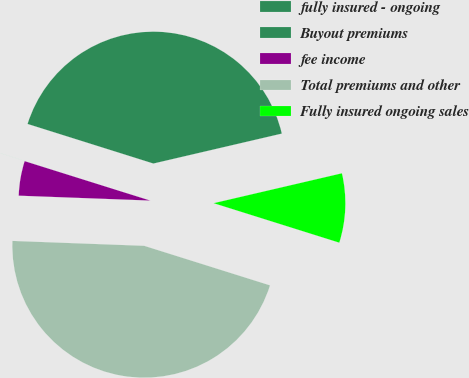Convert chart. <chart><loc_0><loc_0><loc_500><loc_500><pie_chart><fcel>fully insured - ongoing<fcel>Buyout premiums<fcel>fee income<fcel>Total premiums and other<fcel>Fully insured ongoing sales<nl><fcel>41.5%<fcel>0.01%<fcel>4.25%<fcel>45.74%<fcel>8.49%<nl></chart> 